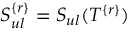Convert formula to latex. <formula><loc_0><loc_0><loc_500><loc_500>S _ { u l } ^ { \{ r \} } = S _ { u l } ( T ^ { \{ r \} } )</formula> 